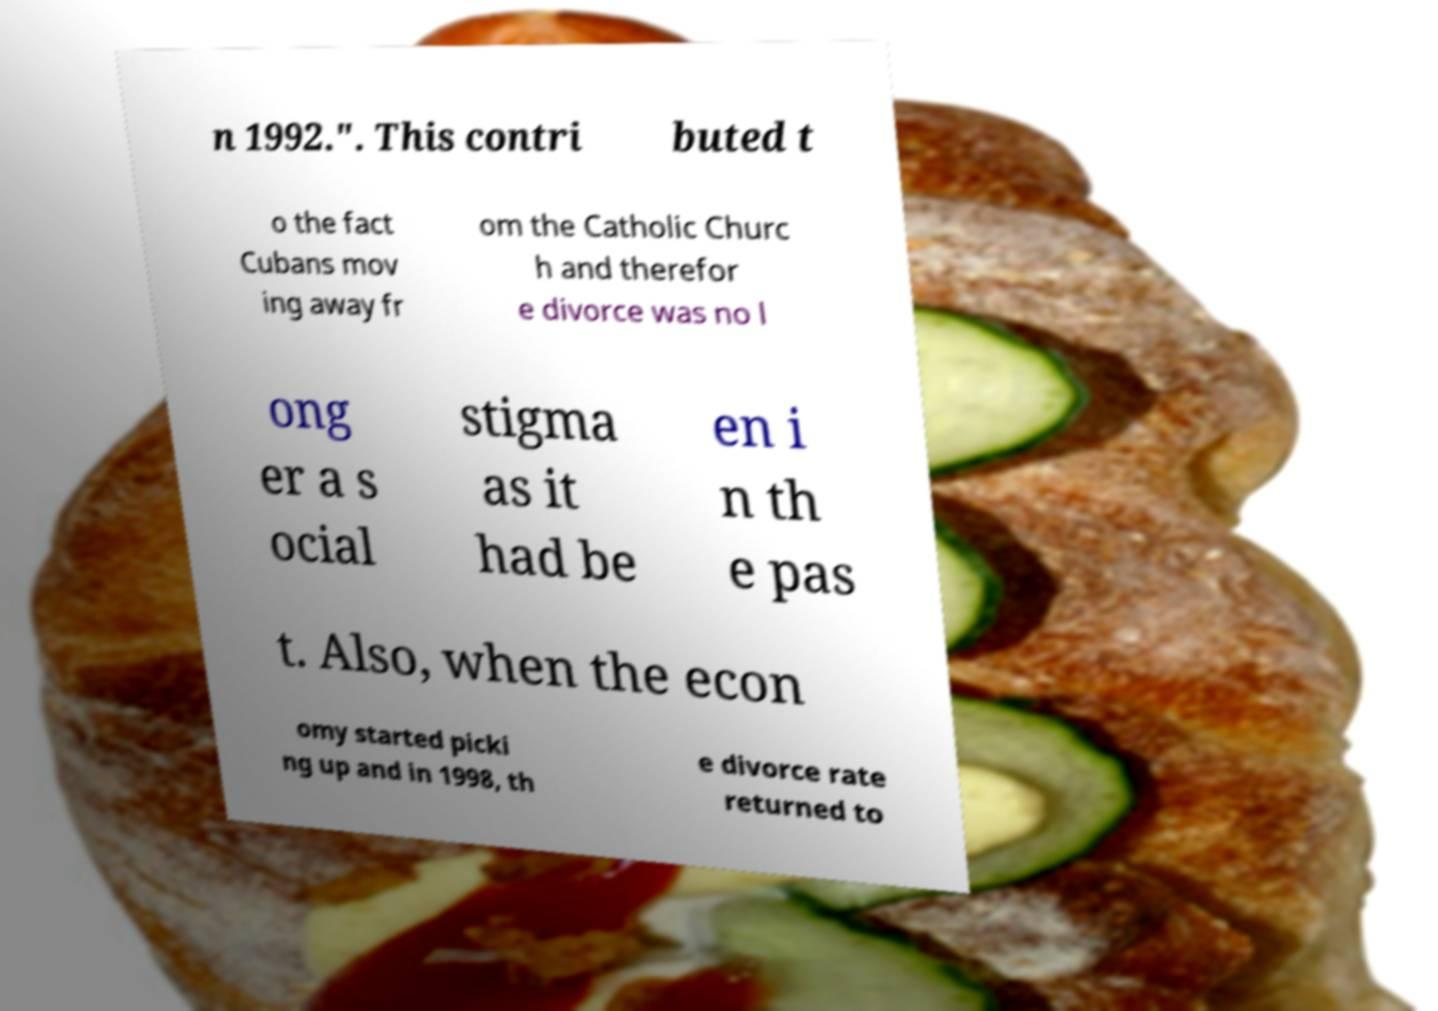Please identify and transcribe the text found in this image. n 1992.". This contri buted t o the fact Cubans mov ing away fr om the Catholic Churc h and therefor e divorce was no l ong er a s ocial stigma as it had be en i n th e pas t. Also, when the econ omy started picki ng up and in 1998, th e divorce rate returned to 